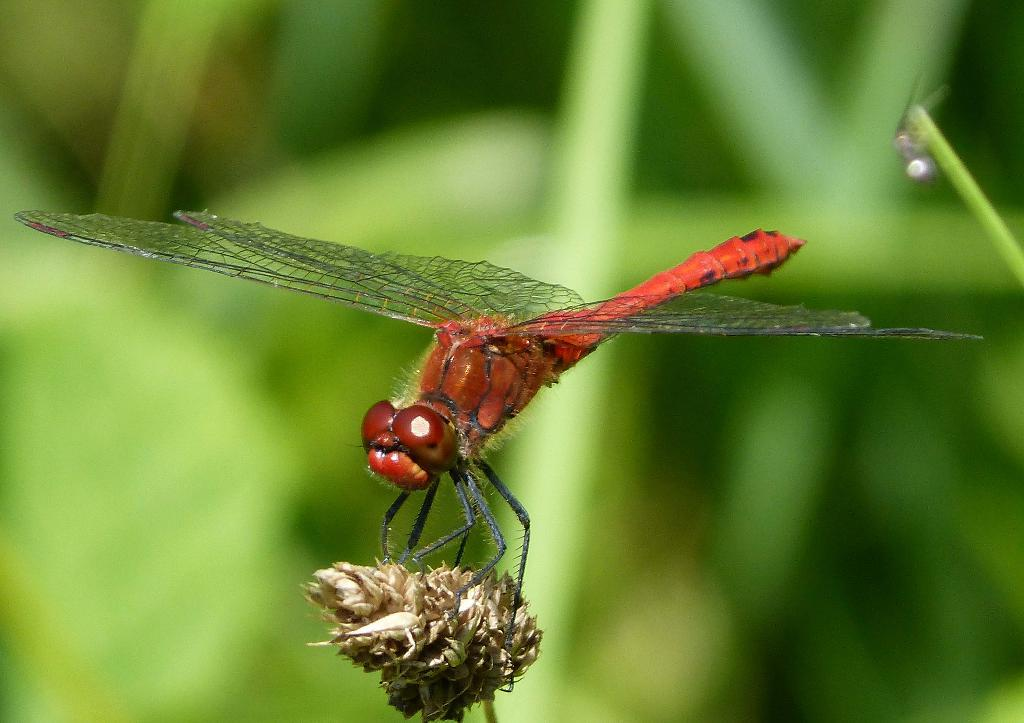What insect is present in the image? There is a dragonfly in the image. What colors can be seen on the dragonfly? The dragonfly has red and black colors. Where is the dragonfly located in the image? The dragonfly is on a flower. What can be seen in the background of the image? There is a plant visible in the background of the image, although it is blurry. What type of operation is being performed on the dragonfly in the image? There is no operation being performed on the dragonfly in the image; it is simply resting on a flower. How many cherries are visible in the image? There are no cherries present in the image. 